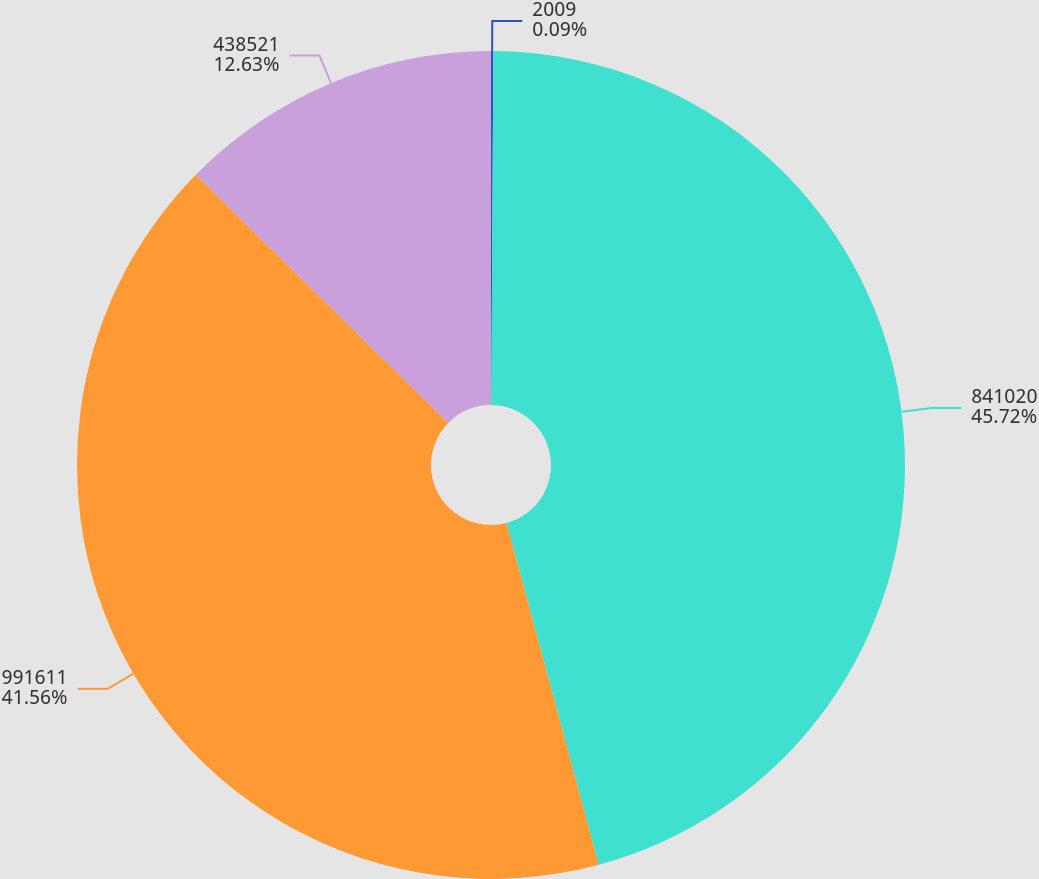Convert chart to OTSL. <chart><loc_0><loc_0><loc_500><loc_500><pie_chart><fcel>2009<fcel>841020<fcel>991611<fcel>438521<nl><fcel>0.09%<fcel>45.72%<fcel>41.56%<fcel>12.63%<nl></chart> 